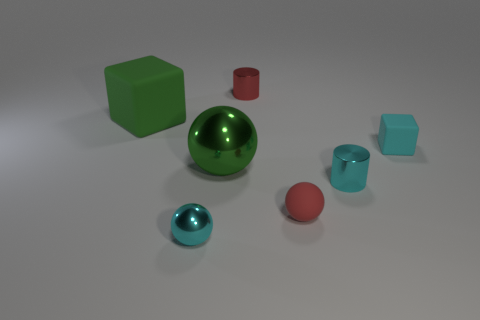Can you tell me the colors of the different spheres in the image? Certainly! In the image, there are two spheres: one is a large, metallic green sphere at the center, while the other is a smaller, glossy red sphere located near the back right in relation to the green sphere. 